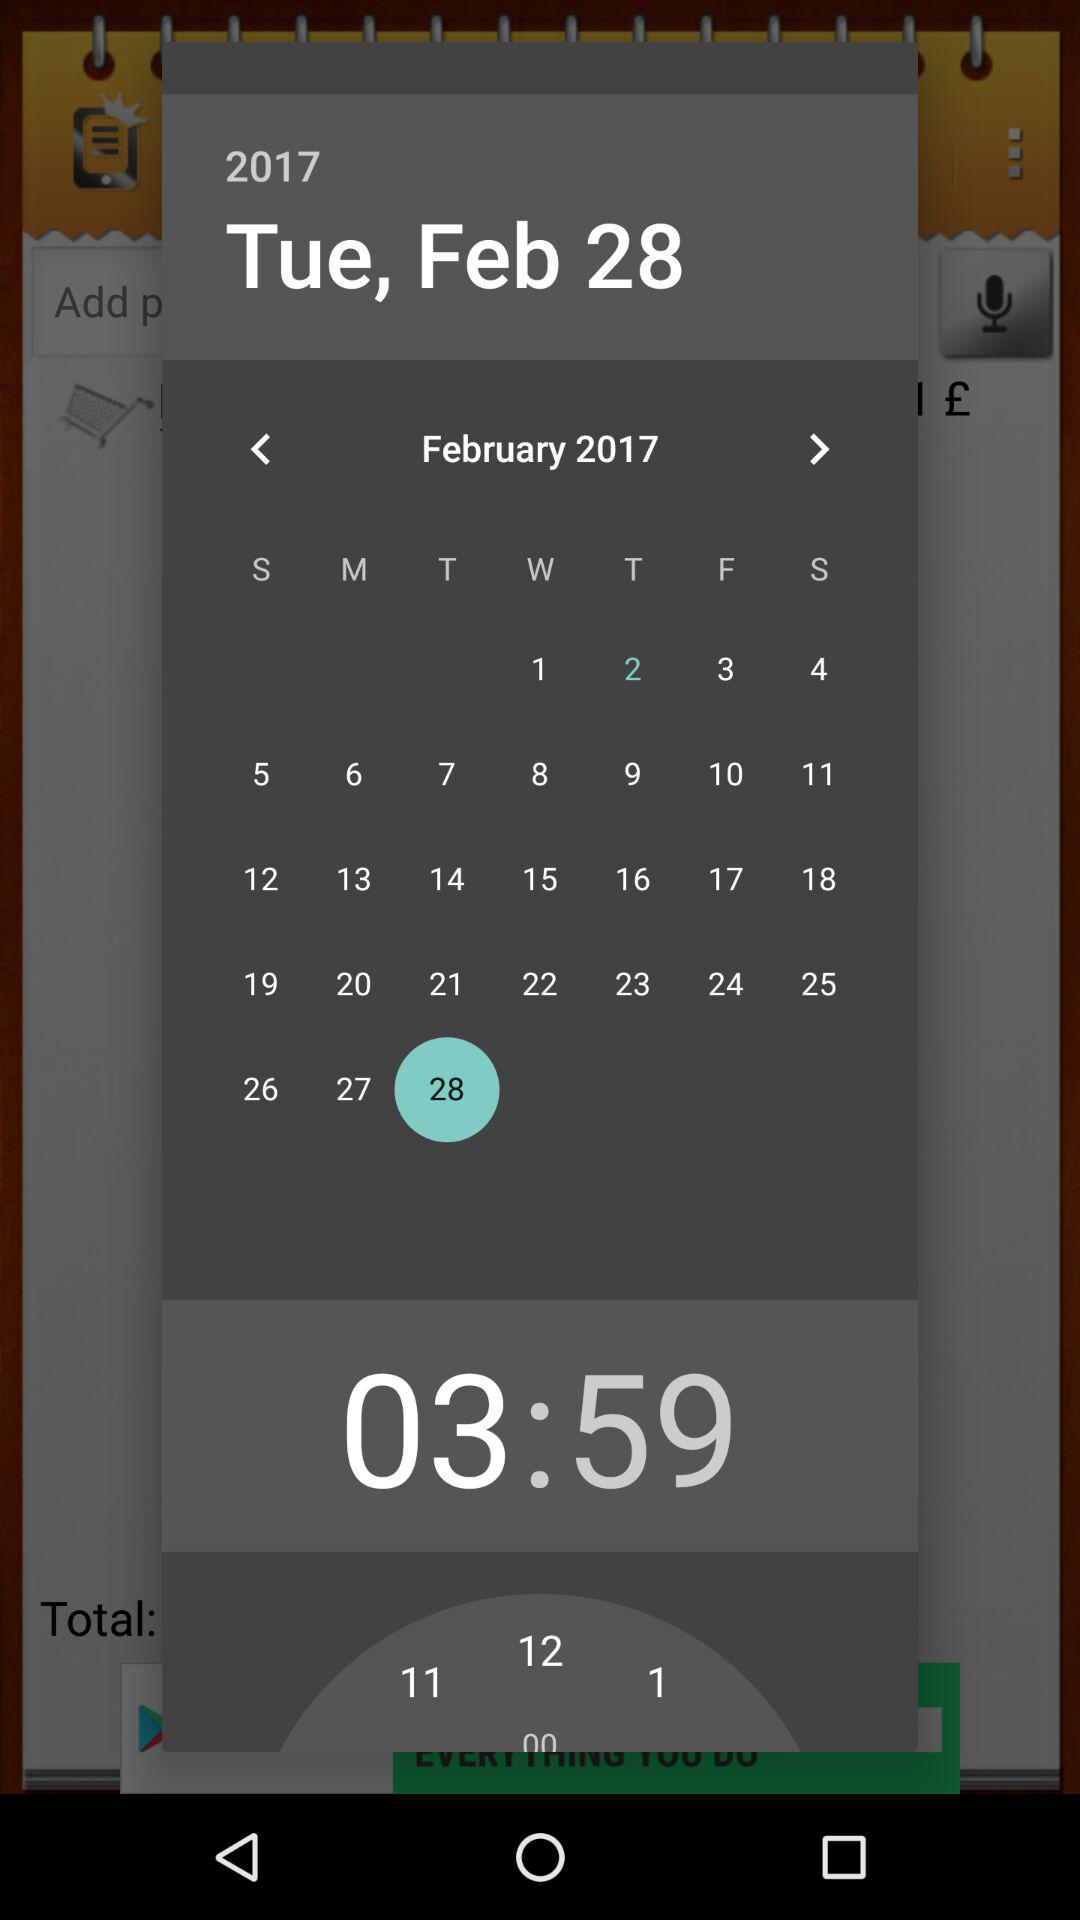Which date is selected? The selected date is Tuesday, April 28, 2017. 